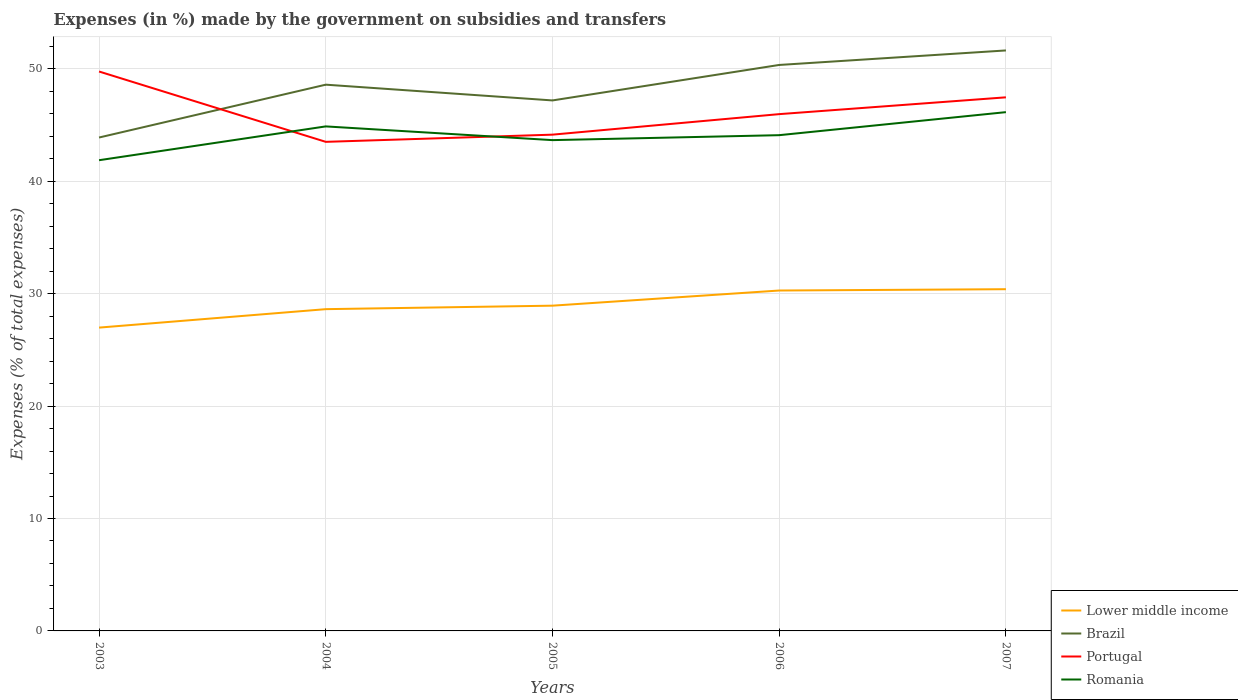How many different coloured lines are there?
Keep it short and to the point. 4. Is the number of lines equal to the number of legend labels?
Make the answer very short. Yes. Across all years, what is the maximum percentage of expenses made by the government on subsidies and transfers in Lower middle income?
Provide a short and direct response. 26.98. What is the total percentage of expenses made by the government on subsidies and transfers in Brazil in the graph?
Your answer should be compact. -3.3. What is the difference between the highest and the second highest percentage of expenses made by the government on subsidies and transfers in Romania?
Offer a very short reply. 4.28. What is the difference between the highest and the lowest percentage of expenses made by the government on subsidies and transfers in Portugal?
Provide a short and direct response. 2. What is the difference between two consecutive major ticks on the Y-axis?
Provide a short and direct response. 10. Does the graph contain grids?
Your response must be concise. Yes. What is the title of the graph?
Provide a short and direct response. Expenses (in %) made by the government on subsidies and transfers. Does "Saudi Arabia" appear as one of the legend labels in the graph?
Provide a succinct answer. No. What is the label or title of the X-axis?
Provide a succinct answer. Years. What is the label or title of the Y-axis?
Offer a terse response. Expenses (% of total expenses). What is the Expenses (% of total expenses) of Lower middle income in 2003?
Ensure brevity in your answer.  26.98. What is the Expenses (% of total expenses) of Brazil in 2003?
Your answer should be compact. 43.89. What is the Expenses (% of total expenses) in Portugal in 2003?
Your response must be concise. 49.76. What is the Expenses (% of total expenses) of Romania in 2003?
Provide a succinct answer. 41.87. What is the Expenses (% of total expenses) of Lower middle income in 2004?
Your answer should be compact. 28.62. What is the Expenses (% of total expenses) in Brazil in 2004?
Provide a short and direct response. 48.59. What is the Expenses (% of total expenses) in Portugal in 2004?
Provide a succinct answer. 43.5. What is the Expenses (% of total expenses) in Romania in 2004?
Provide a succinct answer. 44.87. What is the Expenses (% of total expenses) in Lower middle income in 2005?
Ensure brevity in your answer.  28.93. What is the Expenses (% of total expenses) of Brazil in 2005?
Keep it short and to the point. 47.18. What is the Expenses (% of total expenses) of Portugal in 2005?
Offer a very short reply. 44.14. What is the Expenses (% of total expenses) in Romania in 2005?
Provide a succinct answer. 43.65. What is the Expenses (% of total expenses) in Lower middle income in 2006?
Provide a succinct answer. 30.28. What is the Expenses (% of total expenses) in Brazil in 2006?
Your response must be concise. 50.34. What is the Expenses (% of total expenses) in Portugal in 2006?
Your answer should be compact. 45.97. What is the Expenses (% of total expenses) in Romania in 2006?
Your answer should be compact. 44.1. What is the Expenses (% of total expenses) of Lower middle income in 2007?
Keep it short and to the point. 30.39. What is the Expenses (% of total expenses) in Brazil in 2007?
Offer a very short reply. 51.63. What is the Expenses (% of total expenses) of Portugal in 2007?
Your response must be concise. 47.46. What is the Expenses (% of total expenses) in Romania in 2007?
Your response must be concise. 46.14. Across all years, what is the maximum Expenses (% of total expenses) in Lower middle income?
Ensure brevity in your answer.  30.39. Across all years, what is the maximum Expenses (% of total expenses) in Brazil?
Keep it short and to the point. 51.63. Across all years, what is the maximum Expenses (% of total expenses) of Portugal?
Offer a terse response. 49.76. Across all years, what is the maximum Expenses (% of total expenses) of Romania?
Provide a succinct answer. 46.14. Across all years, what is the minimum Expenses (% of total expenses) in Lower middle income?
Provide a short and direct response. 26.98. Across all years, what is the minimum Expenses (% of total expenses) in Brazil?
Make the answer very short. 43.89. Across all years, what is the minimum Expenses (% of total expenses) in Portugal?
Ensure brevity in your answer.  43.5. Across all years, what is the minimum Expenses (% of total expenses) in Romania?
Your response must be concise. 41.87. What is the total Expenses (% of total expenses) of Lower middle income in the graph?
Give a very brief answer. 145.2. What is the total Expenses (% of total expenses) of Brazil in the graph?
Provide a short and direct response. 241.63. What is the total Expenses (% of total expenses) in Portugal in the graph?
Give a very brief answer. 230.83. What is the total Expenses (% of total expenses) in Romania in the graph?
Offer a terse response. 220.64. What is the difference between the Expenses (% of total expenses) in Lower middle income in 2003 and that in 2004?
Offer a terse response. -1.64. What is the difference between the Expenses (% of total expenses) of Brazil in 2003 and that in 2004?
Make the answer very short. -4.7. What is the difference between the Expenses (% of total expenses) of Portugal in 2003 and that in 2004?
Your response must be concise. 6.26. What is the difference between the Expenses (% of total expenses) in Romania in 2003 and that in 2004?
Ensure brevity in your answer.  -3.01. What is the difference between the Expenses (% of total expenses) of Lower middle income in 2003 and that in 2005?
Give a very brief answer. -1.95. What is the difference between the Expenses (% of total expenses) in Brazil in 2003 and that in 2005?
Your answer should be compact. -3.3. What is the difference between the Expenses (% of total expenses) of Portugal in 2003 and that in 2005?
Your answer should be compact. 5.62. What is the difference between the Expenses (% of total expenses) in Romania in 2003 and that in 2005?
Provide a succinct answer. -1.79. What is the difference between the Expenses (% of total expenses) in Lower middle income in 2003 and that in 2006?
Offer a very short reply. -3.3. What is the difference between the Expenses (% of total expenses) in Brazil in 2003 and that in 2006?
Keep it short and to the point. -6.45. What is the difference between the Expenses (% of total expenses) of Portugal in 2003 and that in 2006?
Offer a terse response. 3.79. What is the difference between the Expenses (% of total expenses) of Romania in 2003 and that in 2006?
Provide a short and direct response. -2.23. What is the difference between the Expenses (% of total expenses) in Lower middle income in 2003 and that in 2007?
Provide a short and direct response. -3.42. What is the difference between the Expenses (% of total expenses) in Brazil in 2003 and that in 2007?
Give a very brief answer. -7.75. What is the difference between the Expenses (% of total expenses) of Portugal in 2003 and that in 2007?
Ensure brevity in your answer.  2.3. What is the difference between the Expenses (% of total expenses) of Romania in 2003 and that in 2007?
Offer a terse response. -4.28. What is the difference between the Expenses (% of total expenses) in Lower middle income in 2004 and that in 2005?
Offer a terse response. -0.31. What is the difference between the Expenses (% of total expenses) in Brazil in 2004 and that in 2005?
Keep it short and to the point. 1.4. What is the difference between the Expenses (% of total expenses) of Portugal in 2004 and that in 2005?
Give a very brief answer. -0.64. What is the difference between the Expenses (% of total expenses) in Romania in 2004 and that in 2005?
Your answer should be very brief. 1.22. What is the difference between the Expenses (% of total expenses) of Lower middle income in 2004 and that in 2006?
Your answer should be compact. -1.66. What is the difference between the Expenses (% of total expenses) of Brazil in 2004 and that in 2006?
Your answer should be very brief. -1.75. What is the difference between the Expenses (% of total expenses) in Portugal in 2004 and that in 2006?
Ensure brevity in your answer.  -2.46. What is the difference between the Expenses (% of total expenses) in Romania in 2004 and that in 2006?
Your answer should be very brief. 0.78. What is the difference between the Expenses (% of total expenses) of Lower middle income in 2004 and that in 2007?
Your answer should be very brief. -1.78. What is the difference between the Expenses (% of total expenses) of Brazil in 2004 and that in 2007?
Keep it short and to the point. -3.05. What is the difference between the Expenses (% of total expenses) in Portugal in 2004 and that in 2007?
Keep it short and to the point. -3.96. What is the difference between the Expenses (% of total expenses) of Romania in 2004 and that in 2007?
Keep it short and to the point. -1.27. What is the difference between the Expenses (% of total expenses) of Lower middle income in 2005 and that in 2006?
Keep it short and to the point. -1.35. What is the difference between the Expenses (% of total expenses) of Brazil in 2005 and that in 2006?
Your answer should be compact. -3.16. What is the difference between the Expenses (% of total expenses) of Portugal in 2005 and that in 2006?
Your answer should be very brief. -1.83. What is the difference between the Expenses (% of total expenses) of Romania in 2005 and that in 2006?
Your answer should be very brief. -0.44. What is the difference between the Expenses (% of total expenses) of Lower middle income in 2005 and that in 2007?
Your answer should be compact. -1.46. What is the difference between the Expenses (% of total expenses) of Brazil in 2005 and that in 2007?
Provide a succinct answer. -4.45. What is the difference between the Expenses (% of total expenses) in Portugal in 2005 and that in 2007?
Provide a short and direct response. -3.32. What is the difference between the Expenses (% of total expenses) of Romania in 2005 and that in 2007?
Your response must be concise. -2.49. What is the difference between the Expenses (% of total expenses) in Lower middle income in 2006 and that in 2007?
Keep it short and to the point. -0.12. What is the difference between the Expenses (% of total expenses) in Brazil in 2006 and that in 2007?
Your answer should be very brief. -1.29. What is the difference between the Expenses (% of total expenses) in Portugal in 2006 and that in 2007?
Make the answer very short. -1.49. What is the difference between the Expenses (% of total expenses) of Romania in 2006 and that in 2007?
Your answer should be very brief. -2.05. What is the difference between the Expenses (% of total expenses) in Lower middle income in 2003 and the Expenses (% of total expenses) in Brazil in 2004?
Offer a terse response. -21.61. What is the difference between the Expenses (% of total expenses) in Lower middle income in 2003 and the Expenses (% of total expenses) in Portugal in 2004?
Provide a short and direct response. -16.52. What is the difference between the Expenses (% of total expenses) in Lower middle income in 2003 and the Expenses (% of total expenses) in Romania in 2004?
Ensure brevity in your answer.  -17.9. What is the difference between the Expenses (% of total expenses) of Brazil in 2003 and the Expenses (% of total expenses) of Portugal in 2004?
Make the answer very short. 0.38. What is the difference between the Expenses (% of total expenses) in Brazil in 2003 and the Expenses (% of total expenses) in Romania in 2004?
Keep it short and to the point. -0.99. What is the difference between the Expenses (% of total expenses) in Portugal in 2003 and the Expenses (% of total expenses) in Romania in 2004?
Keep it short and to the point. 4.88. What is the difference between the Expenses (% of total expenses) of Lower middle income in 2003 and the Expenses (% of total expenses) of Brazil in 2005?
Your answer should be very brief. -20.21. What is the difference between the Expenses (% of total expenses) in Lower middle income in 2003 and the Expenses (% of total expenses) in Portugal in 2005?
Your response must be concise. -17.16. What is the difference between the Expenses (% of total expenses) in Lower middle income in 2003 and the Expenses (% of total expenses) in Romania in 2005?
Offer a terse response. -16.68. What is the difference between the Expenses (% of total expenses) in Brazil in 2003 and the Expenses (% of total expenses) in Portugal in 2005?
Make the answer very short. -0.25. What is the difference between the Expenses (% of total expenses) of Brazil in 2003 and the Expenses (% of total expenses) of Romania in 2005?
Provide a succinct answer. 0.23. What is the difference between the Expenses (% of total expenses) of Portugal in 2003 and the Expenses (% of total expenses) of Romania in 2005?
Offer a terse response. 6.1. What is the difference between the Expenses (% of total expenses) of Lower middle income in 2003 and the Expenses (% of total expenses) of Brazil in 2006?
Keep it short and to the point. -23.36. What is the difference between the Expenses (% of total expenses) in Lower middle income in 2003 and the Expenses (% of total expenses) in Portugal in 2006?
Keep it short and to the point. -18.99. What is the difference between the Expenses (% of total expenses) in Lower middle income in 2003 and the Expenses (% of total expenses) in Romania in 2006?
Make the answer very short. -17.12. What is the difference between the Expenses (% of total expenses) of Brazil in 2003 and the Expenses (% of total expenses) of Portugal in 2006?
Your answer should be very brief. -2.08. What is the difference between the Expenses (% of total expenses) of Brazil in 2003 and the Expenses (% of total expenses) of Romania in 2006?
Your answer should be compact. -0.21. What is the difference between the Expenses (% of total expenses) in Portugal in 2003 and the Expenses (% of total expenses) in Romania in 2006?
Make the answer very short. 5.66. What is the difference between the Expenses (% of total expenses) in Lower middle income in 2003 and the Expenses (% of total expenses) in Brazil in 2007?
Offer a very short reply. -24.65. What is the difference between the Expenses (% of total expenses) in Lower middle income in 2003 and the Expenses (% of total expenses) in Portugal in 2007?
Give a very brief answer. -20.48. What is the difference between the Expenses (% of total expenses) of Lower middle income in 2003 and the Expenses (% of total expenses) of Romania in 2007?
Ensure brevity in your answer.  -19.16. What is the difference between the Expenses (% of total expenses) of Brazil in 2003 and the Expenses (% of total expenses) of Portugal in 2007?
Offer a very short reply. -3.58. What is the difference between the Expenses (% of total expenses) of Brazil in 2003 and the Expenses (% of total expenses) of Romania in 2007?
Keep it short and to the point. -2.26. What is the difference between the Expenses (% of total expenses) in Portugal in 2003 and the Expenses (% of total expenses) in Romania in 2007?
Offer a very short reply. 3.61. What is the difference between the Expenses (% of total expenses) in Lower middle income in 2004 and the Expenses (% of total expenses) in Brazil in 2005?
Keep it short and to the point. -18.57. What is the difference between the Expenses (% of total expenses) in Lower middle income in 2004 and the Expenses (% of total expenses) in Portugal in 2005?
Provide a short and direct response. -15.52. What is the difference between the Expenses (% of total expenses) in Lower middle income in 2004 and the Expenses (% of total expenses) in Romania in 2005?
Provide a succinct answer. -15.04. What is the difference between the Expenses (% of total expenses) of Brazil in 2004 and the Expenses (% of total expenses) of Portugal in 2005?
Provide a succinct answer. 4.45. What is the difference between the Expenses (% of total expenses) in Brazil in 2004 and the Expenses (% of total expenses) in Romania in 2005?
Your answer should be compact. 4.93. What is the difference between the Expenses (% of total expenses) of Portugal in 2004 and the Expenses (% of total expenses) of Romania in 2005?
Your response must be concise. -0.15. What is the difference between the Expenses (% of total expenses) of Lower middle income in 2004 and the Expenses (% of total expenses) of Brazil in 2006?
Your answer should be compact. -21.72. What is the difference between the Expenses (% of total expenses) of Lower middle income in 2004 and the Expenses (% of total expenses) of Portugal in 2006?
Give a very brief answer. -17.35. What is the difference between the Expenses (% of total expenses) of Lower middle income in 2004 and the Expenses (% of total expenses) of Romania in 2006?
Provide a succinct answer. -15.48. What is the difference between the Expenses (% of total expenses) in Brazil in 2004 and the Expenses (% of total expenses) in Portugal in 2006?
Offer a terse response. 2.62. What is the difference between the Expenses (% of total expenses) of Brazil in 2004 and the Expenses (% of total expenses) of Romania in 2006?
Offer a very short reply. 4.49. What is the difference between the Expenses (% of total expenses) of Portugal in 2004 and the Expenses (% of total expenses) of Romania in 2006?
Provide a succinct answer. -0.59. What is the difference between the Expenses (% of total expenses) of Lower middle income in 2004 and the Expenses (% of total expenses) of Brazil in 2007?
Give a very brief answer. -23.01. What is the difference between the Expenses (% of total expenses) of Lower middle income in 2004 and the Expenses (% of total expenses) of Portugal in 2007?
Your answer should be very brief. -18.84. What is the difference between the Expenses (% of total expenses) of Lower middle income in 2004 and the Expenses (% of total expenses) of Romania in 2007?
Give a very brief answer. -17.52. What is the difference between the Expenses (% of total expenses) in Brazil in 2004 and the Expenses (% of total expenses) in Portugal in 2007?
Provide a short and direct response. 1.13. What is the difference between the Expenses (% of total expenses) in Brazil in 2004 and the Expenses (% of total expenses) in Romania in 2007?
Ensure brevity in your answer.  2.44. What is the difference between the Expenses (% of total expenses) of Portugal in 2004 and the Expenses (% of total expenses) of Romania in 2007?
Keep it short and to the point. -2.64. What is the difference between the Expenses (% of total expenses) in Lower middle income in 2005 and the Expenses (% of total expenses) in Brazil in 2006?
Your answer should be compact. -21.41. What is the difference between the Expenses (% of total expenses) of Lower middle income in 2005 and the Expenses (% of total expenses) of Portugal in 2006?
Give a very brief answer. -17.04. What is the difference between the Expenses (% of total expenses) of Lower middle income in 2005 and the Expenses (% of total expenses) of Romania in 2006?
Provide a succinct answer. -15.17. What is the difference between the Expenses (% of total expenses) in Brazil in 2005 and the Expenses (% of total expenses) in Portugal in 2006?
Your answer should be compact. 1.22. What is the difference between the Expenses (% of total expenses) of Brazil in 2005 and the Expenses (% of total expenses) of Romania in 2006?
Ensure brevity in your answer.  3.09. What is the difference between the Expenses (% of total expenses) of Portugal in 2005 and the Expenses (% of total expenses) of Romania in 2006?
Your answer should be compact. 0.05. What is the difference between the Expenses (% of total expenses) of Lower middle income in 2005 and the Expenses (% of total expenses) of Brazil in 2007?
Keep it short and to the point. -22.7. What is the difference between the Expenses (% of total expenses) in Lower middle income in 2005 and the Expenses (% of total expenses) in Portugal in 2007?
Provide a short and direct response. -18.53. What is the difference between the Expenses (% of total expenses) in Lower middle income in 2005 and the Expenses (% of total expenses) in Romania in 2007?
Your answer should be very brief. -17.21. What is the difference between the Expenses (% of total expenses) in Brazil in 2005 and the Expenses (% of total expenses) in Portugal in 2007?
Your response must be concise. -0.28. What is the difference between the Expenses (% of total expenses) in Brazil in 2005 and the Expenses (% of total expenses) in Romania in 2007?
Provide a short and direct response. 1.04. What is the difference between the Expenses (% of total expenses) in Portugal in 2005 and the Expenses (% of total expenses) in Romania in 2007?
Your response must be concise. -2. What is the difference between the Expenses (% of total expenses) of Lower middle income in 2006 and the Expenses (% of total expenses) of Brazil in 2007?
Provide a succinct answer. -21.35. What is the difference between the Expenses (% of total expenses) of Lower middle income in 2006 and the Expenses (% of total expenses) of Portugal in 2007?
Offer a terse response. -17.18. What is the difference between the Expenses (% of total expenses) of Lower middle income in 2006 and the Expenses (% of total expenses) of Romania in 2007?
Your response must be concise. -15.87. What is the difference between the Expenses (% of total expenses) of Brazil in 2006 and the Expenses (% of total expenses) of Portugal in 2007?
Your response must be concise. 2.88. What is the difference between the Expenses (% of total expenses) of Brazil in 2006 and the Expenses (% of total expenses) of Romania in 2007?
Your answer should be compact. 4.2. What is the difference between the Expenses (% of total expenses) of Portugal in 2006 and the Expenses (% of total expenses) of Romania in 2007?
Offer a very short reply. -0.18. What is the average Expenses (% of total expenses) in Lower middle income per year?
Keep it short and to the point. 29.04. What is the average Expenses (% of total expenses) in Brazil per year?
Provide a succinct answer. 48.33. What is the average Expenses (% of total expenses) in Portugal per year?
Your answer should be compact. 46.17. What is the average Expenses (% of total expenses) of Romania per year?
Make the answer very short. 44.13. In the year 2003, what is the difference between the Expenses (% of total expenses) of Lower middle income and Expenses (% of total expenses) of Brazil?
Your answer should be compact. -16.91. In the year 2003, what is the difference between the Expenses (% of total expenses) of Lower middle income and Expenses (% of total expenses) of Portugal?
Your response must be concise. -22.78. In the year 2003, what is the difference between the Expenses (% of total expenses) of Lower middle income and Expenses (% of total expenses) of Romania?
Your answer should be very brief. -14.89. In the year 2003, what is the difference between the Expenses (% of total expenses) in Brazil and Expenses (% of total expenses) in Portugal?
Provide a succinct answer. -5.87. In the year 2003, what is the difference between the Expenses (% of total expenses) of Brazil and Expenses (% of total expenses) of Romania?
Offer a very short reply. 2.02. In the year 2003, what is the difference between the Expenses (% of total expenses) of Portugal and Expenses (% of total expenses) of Romania?
Provide a succinct answer. 7.89. In the year 2004, what is the difference between the Expenses (% of total expenses) in Lower middle income and Expenses (% of total expenses) in Brazil?
Give a very brief answer. -19.97. In the year 2004, what is the difference between the Expenses (% of total expenses) of Lower middle income and Expenses (% of total expenses) of Portugal?
Offer a very short reply. -14.88. In the year 2004, what is the difference between the Expenses (% of total expenses) of Lower middle income and Expenses (% of total expenses) of Romania?
Keep it short and to the point. -16.26. In the year 2004, what is the difference between the Expenses (% of total expenses) of Brazil and Expenses (% of total expenses) of Portugal?
Keep it short and to the point. 5.08. In the year 2004, what is the difference between the Expenses (% of total expenses) in Brazil and Expenses (% of total expenses) in Romania?
Give a very brief answer. 3.71. In the year 2004, what is the difference between the Expenses (% of total expenses) of Portugal and Expenses (% of total expenses) of Romania?
Provide a succinct answer. -1.37. In the year 2005, what is the difference between the Expenses (% of total expenses) of Lower middle income and Expenses (% of total expenses) of Brazil?
Give a very brief answer. -18.26. In the year 2005, what is the difference between the Expenses (% of total expenses) of Lower middle income and Expenses (% of total expenses) of Portugal?
Your response must be concise. -15.21. In the year 2005, what is the difference between the Expenses (% of total expenses) of Lower middle income and Expenses (% of total expenses) of Romania?
Give a very brief answer. -14.72. In the year 2005, what is the difference between the Expenses (% of total expenses) of Brazil and Expenses (% of total expenses) of Portugal?
Offer a terse response. 3.04. In the year 2005, what is the difference between the Expenses (% of total expenses) in Brazil and Expenses (% of total expenses) in Romania?
Keep it short and to the point. 3.53. In the year 2005, what is the difference between the Expenses (% of total expenses) in Portugal and Expenses (% of total expenses) in Romania?
Ensure brevity in your answer.  0.49. In the year 2006, what is the difference between the Expenses (% of total expenses) of Lower middle income and Expenses (% of total expenses) of Brazil?
Keep it short and to the point. -20.06. In the year 2006, what is the difference between the Expenses (% of total expenses) in Lower middle income and Expenses (% of total expenses) in Portugal?
Provide a succinct answer. -15.69. In the year 2006, what is the difference between the Expenses (% of total expenses) of Lower middle income and Expenses (% of total expenses) of Romania?
Offer a very short reply. -13.82. In the year 2006, what is the difference between the Expenses (% of total expenses) of Brazil and Expenses (% of total expenses) of Portugal?
Keep it short and to the point. 4.37. In the year 2006, what is the difference between the Expenses (% of total expenses) of Brazil and Expenses (% of total expenses) of Romania?
Your answer should be very brief. 6.25. In the year 2006, what is the difference between the Expenses (% of total expenses) in Portugal and Expenses (% of total expenses) in Romania?
Provide a short and direct response. 1.87. In the year 2007, what is the difference between the Expenses (% of total expenses) of Lower middle income and Expenses (% of total expenses) of Brazil?
Ensure brevity in your answer.  -21.24. In the year 2007, what is the difference between the Expenses (% of total expenses) in Lower middle income and Expenses (% of total expenses) in Portugal?
Your answer should be compact. -17.07. In the year 2007, what is the difference between the Expenses (% of total expenses) in Lower middle income and Expenses (% of total expenses) in Romania?
Your answer should be very brief. -15.75. In the year 2007, what is the difference between the Expenses (% of total expenses) of Brazil and Expenses (% of total expenses) of Portugal?
Make the answer very short. 4.17. In the year 2007, what is the difference between the Expenses (% of total expenses) of Brazil and Expenses (% of total expenses) of Romania?
Offer a terse response. 5.49. In the year 2007, what is the difference between the Expenses (% of total expenses) in Portugal and Expenses (% of total expenses) in Romania?
Offer a very short reply. 1.32. What is the ratio of the Expenses (% of total expenses) in Lower middle income in 2003 to that in 2004?
Give a very brief answer. 0.94. What is the ratio of the Expenses (% of total expenses) of Brazil in 2003 to that in 2004?
Your answer should be compact. 0.9. What is the ratio of the Expenses (% of total expenses) of Portugal in 2003 to that in 2004?
Ensure brevity in your answer.  1.14. What is the ratio of the Expenses (% of total expenses) of Romania in 2003 to that in 2004?
Your answer should be compact. 0.93. What is the ratio of the Expenses (% of total expenses) of Lower middle income in 2003 to that in 2005?
Your answer should be very brief. 0.93. What is the ratio of the Expenses (% of total expenses) of Brazil in 2003 to that in 2005?
Your response must be concise. 0.93. What is the ratio of the Expenses (% of total expenses) in Portugal in 2003 to that in 2005?
Offer a very short reply. 1.13. What is the ratio of the Expenses (% of total expenses) of Romania in 2003 to that in 2005?
Offer a very short reply. 0.96. What is the ratio of the Expenses (% of total expenses) in Lower middle income in 2003 to that in 2006?
Give a very brief answer. 0.89. What is the ratio of the Expenses (% of total expenses) in Brazil in 2003 to that in 2006?
Your answer should be compact. 0.87. What is the ratio of the Expenses (% of total expenses) in Portugal in 2003 to that in 2006?
Make the answer very short. 1.08. What is the ratio of the Expenses (% of total expenses) of Romania in 2003 to that in 2006?
Provide a succinct answer. 0.95. What is the ratio of the Expenses (% of total expenses) of Lower middle income in 2003 to that in 2007?
Your response must be concise. 0.89. What is the ratio of the Expenses (% of total expenses) in Brazil in 2003 to that in 2007?
Your response must be concise. 0.85. What is the ratio of the Expenses (% of total expenses) of Portugal in 2003 to that in 2007?
Make the answer very short. 1.05. What is the ratio of the Expenses (% of total expenses) of Romania in 2003 to that in 2007?
Your response must be concise. 0.91. What is the ratio of the Expenses (% of total expenses) in Lower middle income in 2004 to that in 2005?
Keep it short and to the point. 0.99. What is the ratio of the Expenses (% of total expenses) of Brazil in 2004 to that in 2005?
Ensure brevity in your answer.  1.03. What is the ratio of the Expenses (% of total expenses) of Portugal in 2004 to that in 2005?
Provide a short and direct response. 0.99. What is the ratio of the Expenses (% of total expenses) in Romania in 2004 to that in 2005?
Make the answer very short. 1.03. What is the ratio of the Expenses (% of total expenses) of Lower middle income in 2004 to that in 2006?
Your answer should be very brief. 0.95. What is the ratio of the Expenses (% of total expenses) in Brazil in 2004 to that in 2006?
Your response must be concise. 0.97. What is the ratio of the Expenses (% of total expenses) of Portugal in 2004 to that in 2006?
Your answer should be compact. 0.95. What is the ratio of the Expenses (% of total expenses) of Romania in 2004 to that in 2006?
Your answer should be very brief. 1.02. What is the ratio of the Expenses (% of total expenses) of Lower middle income in 2004 to that in 2007?
Offer a very short reply. 0.94. What is the ratio of the Expenses (% of total expenses) in Brazil in 2004 to that in 2007?
Your response must be concise. 0.94. What is the ratio of the Expenses (% of total expenses) of Portugal in 2004 to that in 2007?
Offer a very short reply. 0.92. What is the ratio of the Expenses (% of total expenses) of Romania in 2004 to that in 2007?
Give a very brief answer. 0.97. What is the ratio of the Expenses (% of total expenses) in Lower middle income in 2005 to that in 2006?
Make the answer very short. 0.96. What is the ratio of the Expenses (% of total expenses) of Brazil in 2005 to that in 2006?
Provide a succinct answer. 0.94. What is the ratio of the Expenses (% of total expenses) of Portugal in 2005 to that in 2006?
Offer a terse response. 0.96. What is the ratio of the Expenses (% of total expenses) in Romania in 2005 to that in 2006?
Give a very brief answer. 0.99. What is the ratio of the Expenses (% of total expenses) of Lower middle income in 2005 to that in 2007?
Provide a succinct answer. 0.95. What is the ratio of the Expenses (% of total expenses) in Brazil in 2005 to that in 2007?
Keep it short and to the point. 0.91. What is the ratio of the Expenses (% of total expenses) in Romania in 2005 to that in 2007?
Ensure brevity in your answer.  0.95. What is the ratio of the Expenses (% of total expenses) in Brazil in 2006 to that in 2007?
Give a very brief answer. 0.97. What is the ratio of the Expenses (% of total expenses) of Portugal in 2006 to that in 2007?
Keep it short and to the point. 0.97. What is the ratio of the Expenses (% of total expenses) in Romania in 2006 to that in 2007?
Give a very brief answer. 0.96. What is the difference between the highest and the second highest Expenses (% of total expenses) of Lower middle income?
Your answer should be compact. 0.12. What is the difference between the highest and the second highest Expenses (% of total expenses) of Brazil?
Offer a terse response. 1.29. What is the difference between the highest and the second highest Expenses (% of total expenses) in Portugal?
Offer a very short reply. 2.3. What is the difference between the highest and the second highest Expenses (% of total expenses) of Romania?
Keep it short and to the point. 1.27. What is the difference between the highest and the lowest Expenses (% of total expenses) of Lower middle income?
Provide a succinct answer. 3.42. What is the difference between the highest and the lowest Expenses (% of total expenses) of Brazil?
Offer a very short reply. 7.75. What is the difference between the highest and the lowest Expenses (% of total expenses) of Portugal?
Your response must be concise. 6.26. What is the difference between the highest and the lowest Expenses (% of total expenses) of Romania?
Keep it short and to the point. 4.28. 